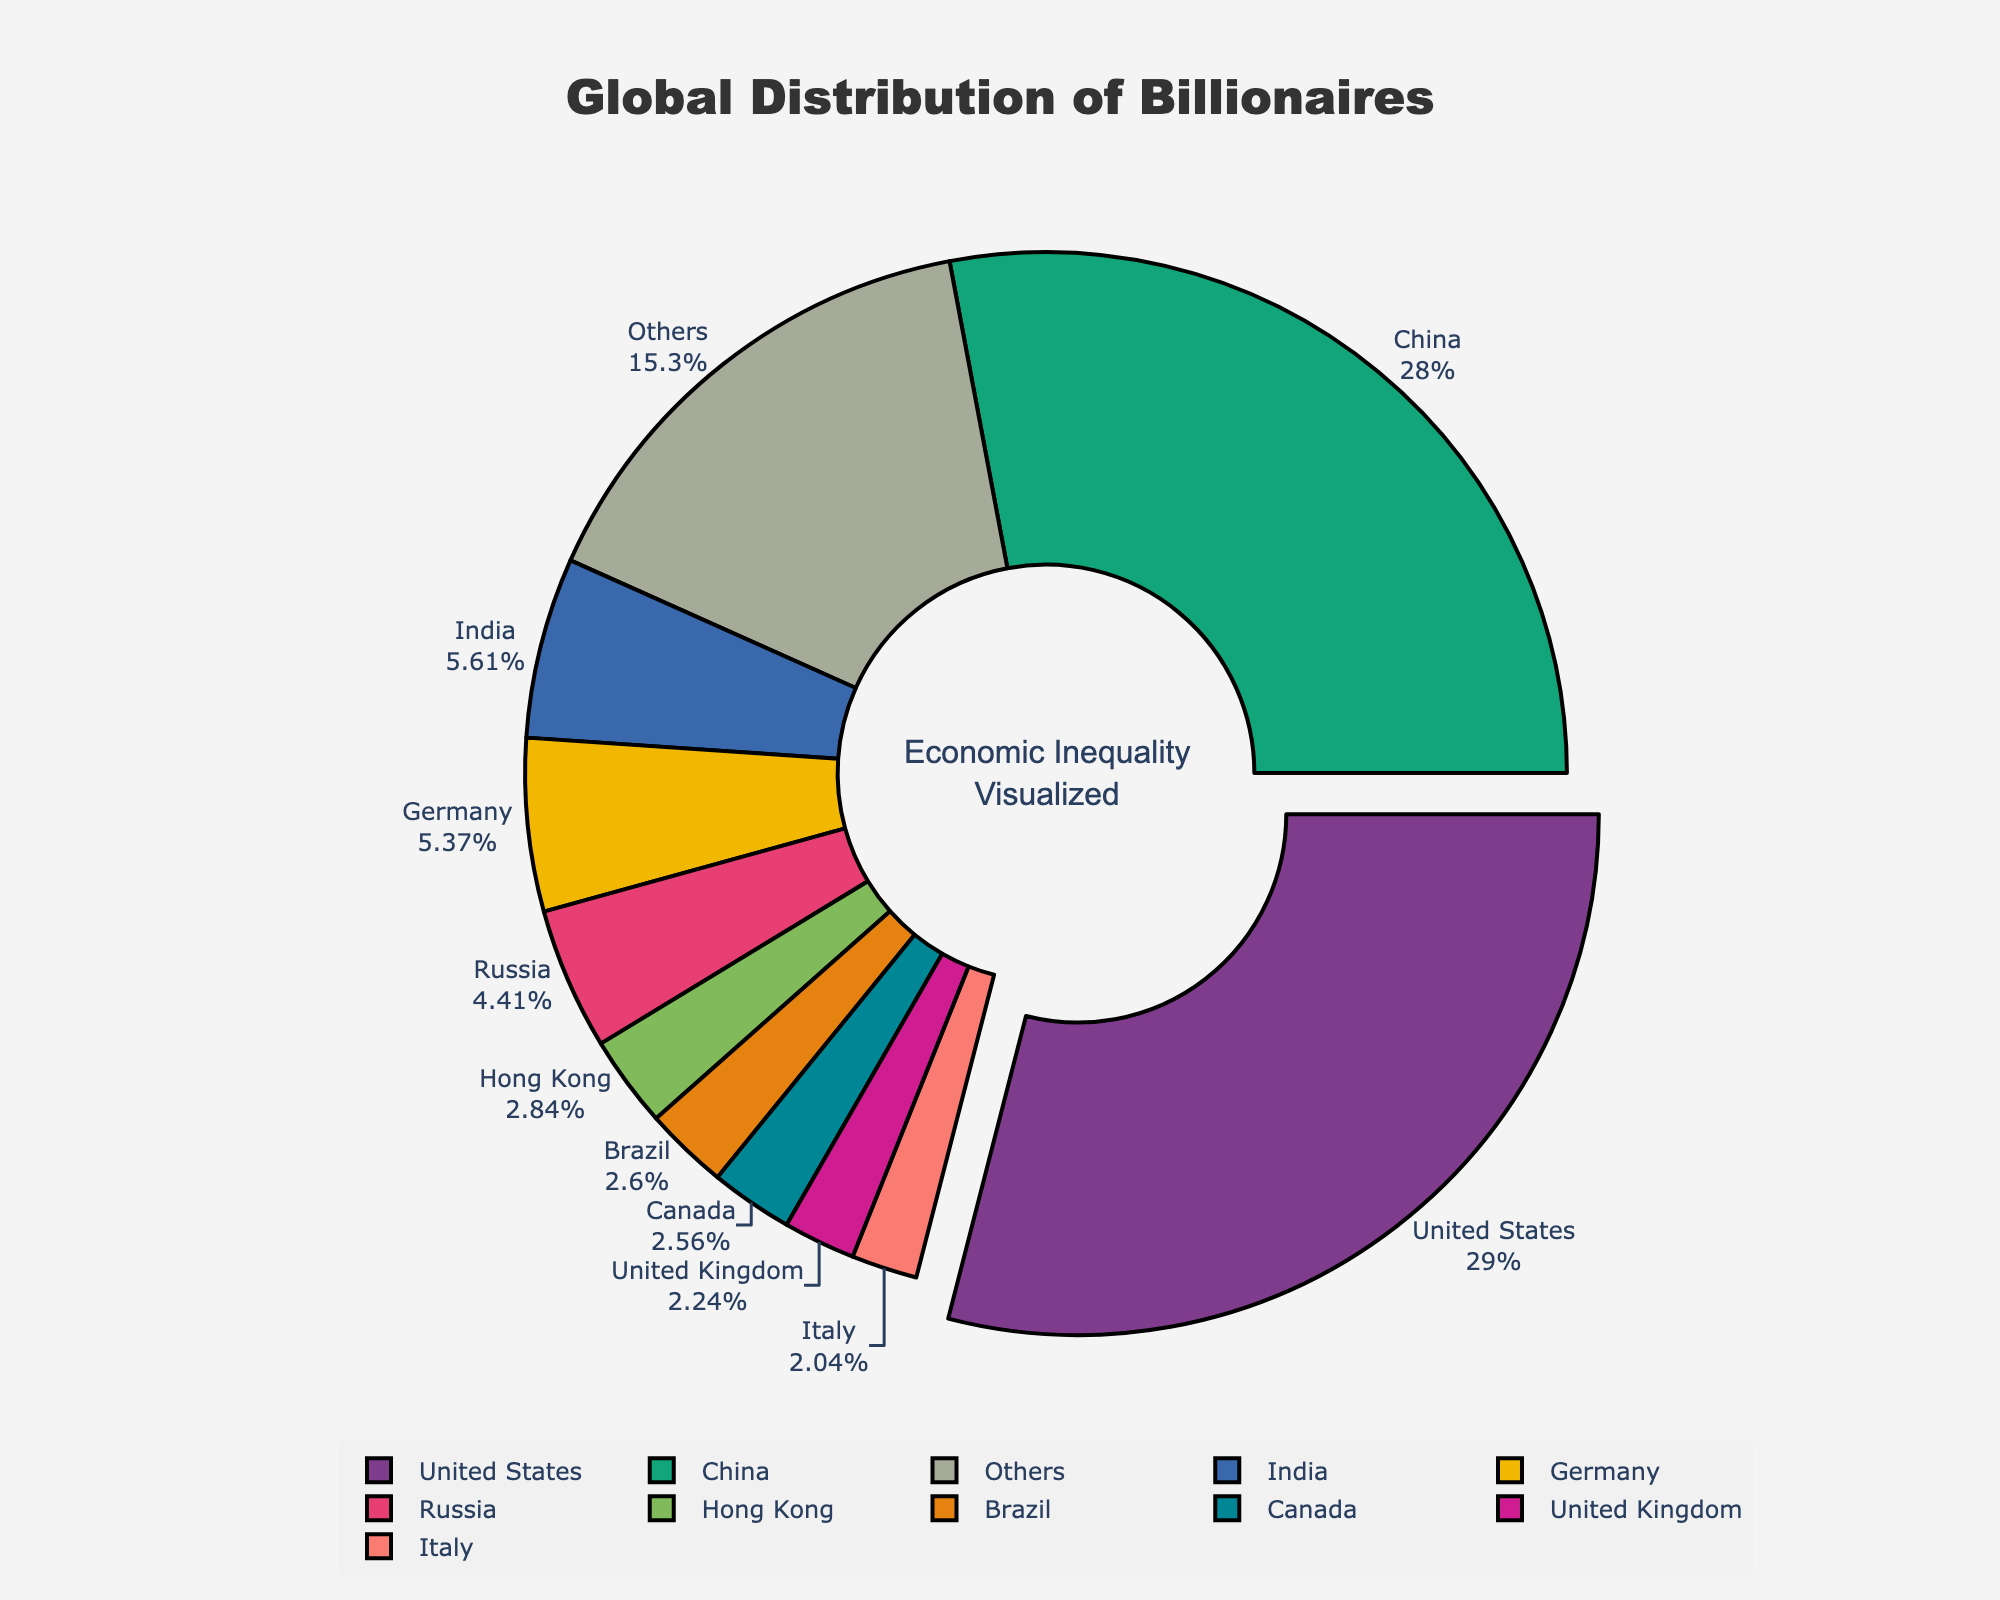What percentage of billionaires are in the United States? The pie chart shows each country's percentage of the total number of billionaires. To find the percentage for the United States, we simply refer to its segment labeled with the percentage.
Answer: 28.6% Which country has the second-highest number of billionaires, and what percentage do they represent? According to the pie chart, the segment representing China is labeled with both the count and the percentage, showing it as the second highest in number.
Answer: China, 27.6% How many more billionaires are there in the United States compared to India? From the chart, the United States has 724 billionaires and India has 140. Subtracting India's total from the United States' total gives 724 - 140.
Answer: 584 Which countries are included in the "Others" category and what is their combined number of billionaires? The chart shows a segment labeled "Others". To determine the countries included, observe that "Others" includes the countries not represented in the top 10. Sum the number of billionaires of these remaining countries: Russia, Hong Kong, Brazil, Canada, United Kingdom, Italy, France, Switzerland, Japan, Australia, Singapore, Sweden, South Korea, Spain, Thailand, Indonesia, Turkey, Israel, Mexico, Netherlands, and Philippines (110 + 71 + 65 + 64 + 56 + 51 + 42 + 41 + 40 + 38 + 26 + 26 + 25 + 24 + 21 + 20 + 18 + 17 + 16 + 15 + 14).
Answer: 709 What is the combined percentage of billionaires in the top three countries? According to the pie chart, the top three countries by number of billionaires are the United States, China, and India. The percentages are 28.6%, 27.6%, and 5.5%, respectively. Adding these percentages together gives 28.6 + 27.6 + 5.5.
Answer: 61.7% Between Germany and Russia, which country has a greater number of billionaires and by what margin? The pie chart lists Germany with 134 billionaires and Russia with 110 billionaires. Subtracting Russia's total from Germany's total gives 134 - 110.
Answer: Germany by 24 Is the number of billionaires in the "Others" category greater or less than in China? According to the chart, China has 698 billionaires. The "Others" segment has a combined total of 709 billionaires. Comparing these numbers shows that the "Others" category is greater than China.
Answer: Greater What is the average number of billionaires in the top 10 countries? The top 10 countries listed are the United States, China, India, Germany, Russia, Hong Kong, Brazil, Canada, United Kingdom, and Italy. Their respective numbers of billionaires are 724, 698, 140, 134, 110, 71, 65, 64, 56, and 51. Summing these values gives 2113. To find the average, divide by 10.
Answer: 211.3 